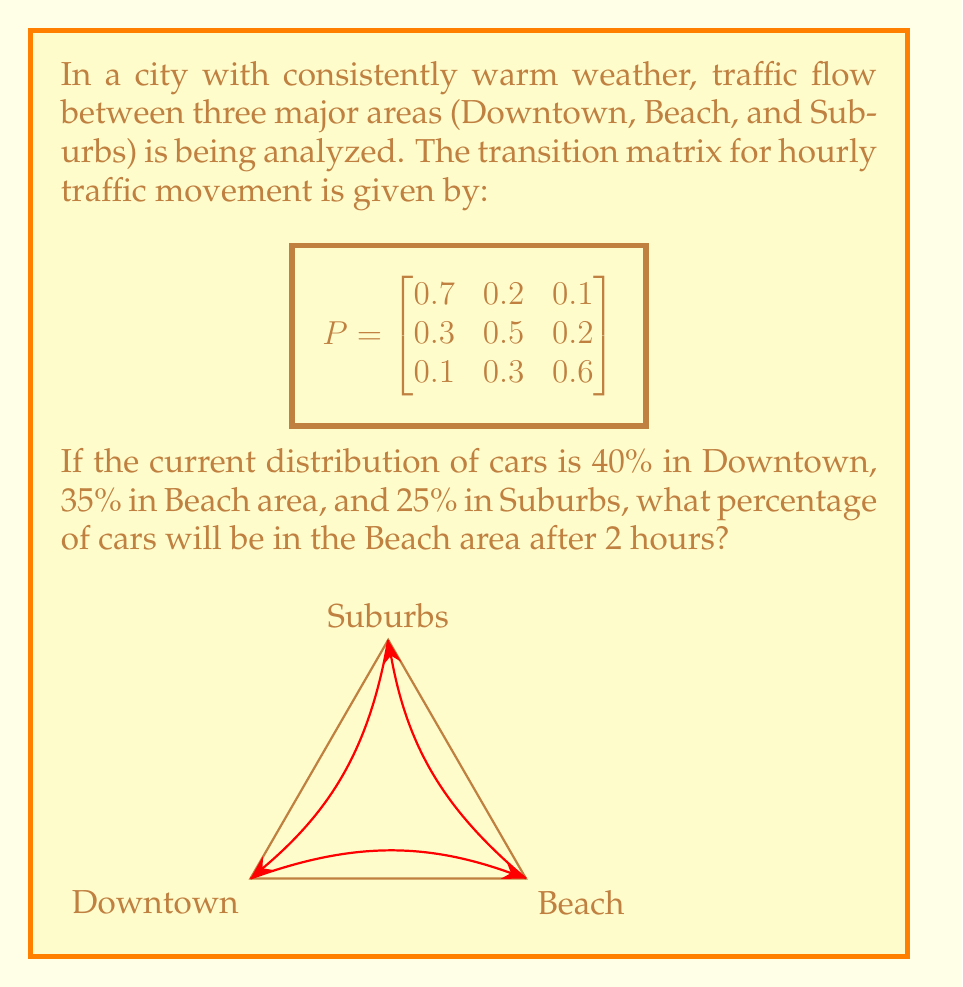Show me your answer to this math problem. Let's approach this step-by-step:

1) First, we need to represent the initial distribution as a row vector:
   $$v_0 = \begin{bmatrix} 0.4 & 0.35 & 0.25 \end{bmatrix}$$

2) To find the distribution after 2 hours, we need to multiply this vector by the transition matrix twice:
   $$v_2 = v_0 \cdot P^2$$

3) Let's calculate $P^2$ first:
   $$P^2 = P \cdot P = \begin{bmatrix}
   0.7 & 0.2 & 0.1 \\
   0.3 & 0.5 & 0.2 \\
   0.1 & 0.3 & 0.6
   \end{bmatrix} \cdot \begin{bmatrix}
   0.7 & 0.2 & 0.1 \\
   0.3 & 0.5 & 0.2 \\
   0.1 & 0.3 & 0.6
   \end{bmatrix}$$

4) Multiplying these matrices:
   $$P^2 = \begin{bmatrix}
   0.58 & 0.27 & 0.15 \\
   0.39 & 0.41 & 0.20 \\
   0.22 & 0.37 & 0.41
   \end{bmatrix}$$

5) Now, we multiply $v_0$ by $P^2$:
   $$v_2 = \begin{bmatrix} 0.4 & 0.35 & 0.25 \end{bmatrix} \cdot \begin{bmatrix}
   0.58 & 0.27 & 0.15 \\
   0.39 & 0.41 & 0.20 \\
   0.22 & 0.37 & 0.41
   \end{bmatrix}$$

6) Calculating this:
   $$v_2 = \begin{bmatrix} 0.4390 & 0.3390 & 0.2220 \end{bmatrix}$$

7) The second element of this vector represents the proportion of cars in the Beach area after 2 hours.

8) Converting to a percentage: $0.3390 \times 100\% = 33.90\%$
Answer: 33.90% 